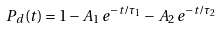<formula> <loc_0><loc_0><loc_500><loc_500>P _ { d } ( t ) = 1 - A _ { 1 } \, e ^ { - t / \tau _ { 1 } } - A _ { 2 } \, e ^ { - t / \tau _ { 2 } } \,</formula> 